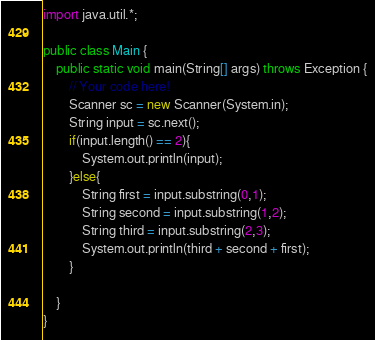<code> <loc_0><loc_0><loc_500><loc_500><_Java_>import java.util.*;

public class Main {
    public static void main(String[] args) throws Exception {
        // Your code here!
        Scanner sc = new Scanner(System.in);
        String input = sc.next();
        if(input.length() == 2){
            System.out.println(input);
        }else{
            String first = input.substring(0,1);
            String second = input.substring(1,2);
            String third = input.substring(2,3);
            System.out.println(third + second + first);
        }
        
    }
}
</code> 